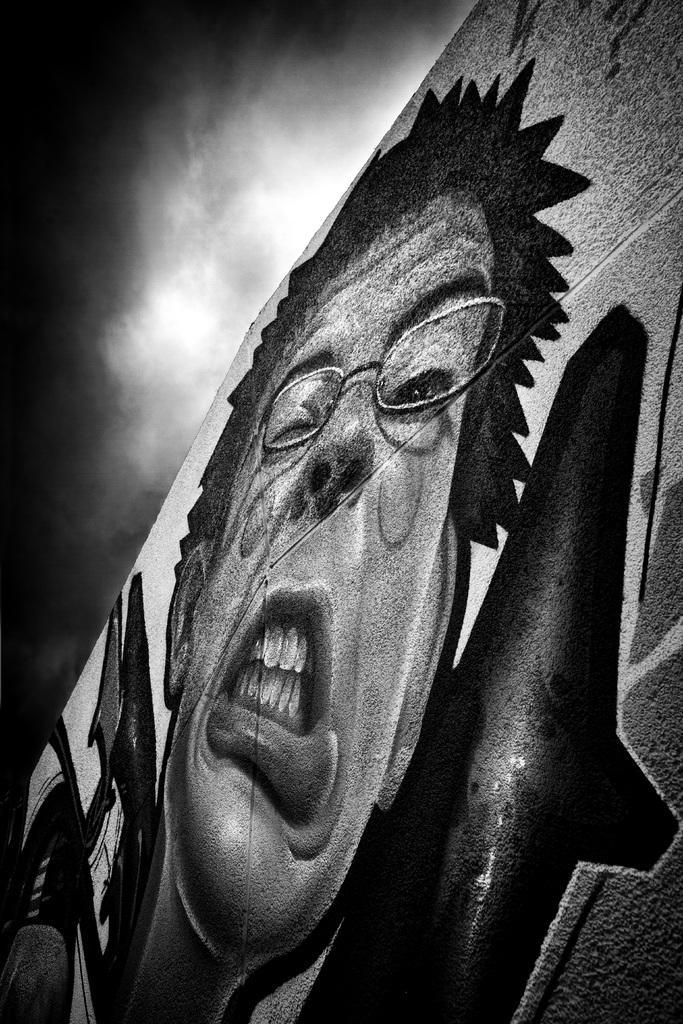How would you summarize this image in a sentence or two? In this image there is a painting of a person on the wall. In the background there is the sky. 